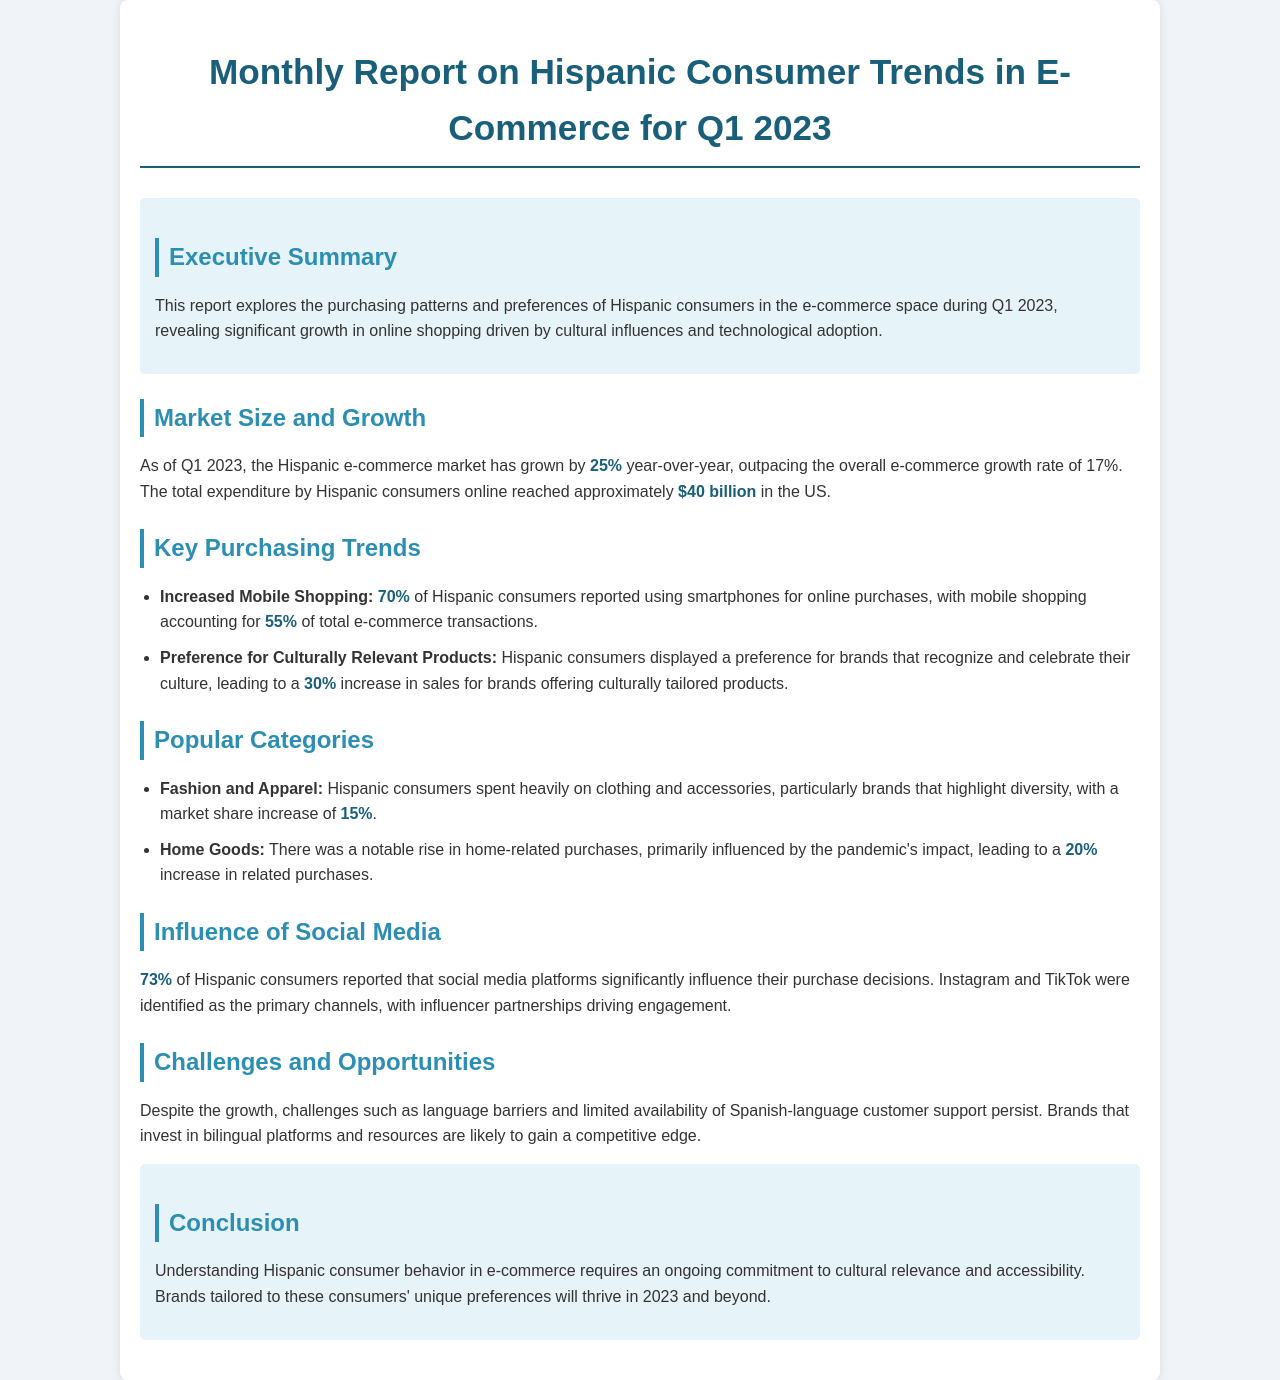What is the growth rate of the Hispanic e-commerce market? The document states that the Hispanic e-commerce market has grown by 25% year-over-year.
Answer: 25% What was the total expenditure by Hispanic consumers online in Q1 2023? The total expenditure by Hispanic consumers online reached approximately $40 billion.
Answer: $40 billion What percentage of Hispanic consumers reported using smartphones for online purchases? The report indicates that 70% of Hispanic consumers used smartphones for online purchases.
Answer: 70% Which social media platforms significantly influence purchase decisions for Hispanic consumers? The primary platforms identified are Instagram and TikTok.
Answer: Instagram and TikTok What is the percentage increase in sales for brands offering culturally tailored products? The document notes a 30% increase in sales for these brands.
Answer: 30% Which category saw a 15% market share increase among Hispanic consumers? The category that saw this increase is Fashion and Apparel.
Answer: Fashion and Apparel What percentage of total e-commerce transactions does mobile shopping account for? Mobile shopping accounts for 55% of total e-commerce transactions.
Answer: 55% What challenge is mentioned that affects Hispanic consumers in e-commerce? One challenge mentioned is language barriers.
Answer: Language barriers What is highlighted as a successful investment for brands? Investing in bilingual platforms and resources is highlighted as a successful investment.
Answer: Bilingual platforms and resources 